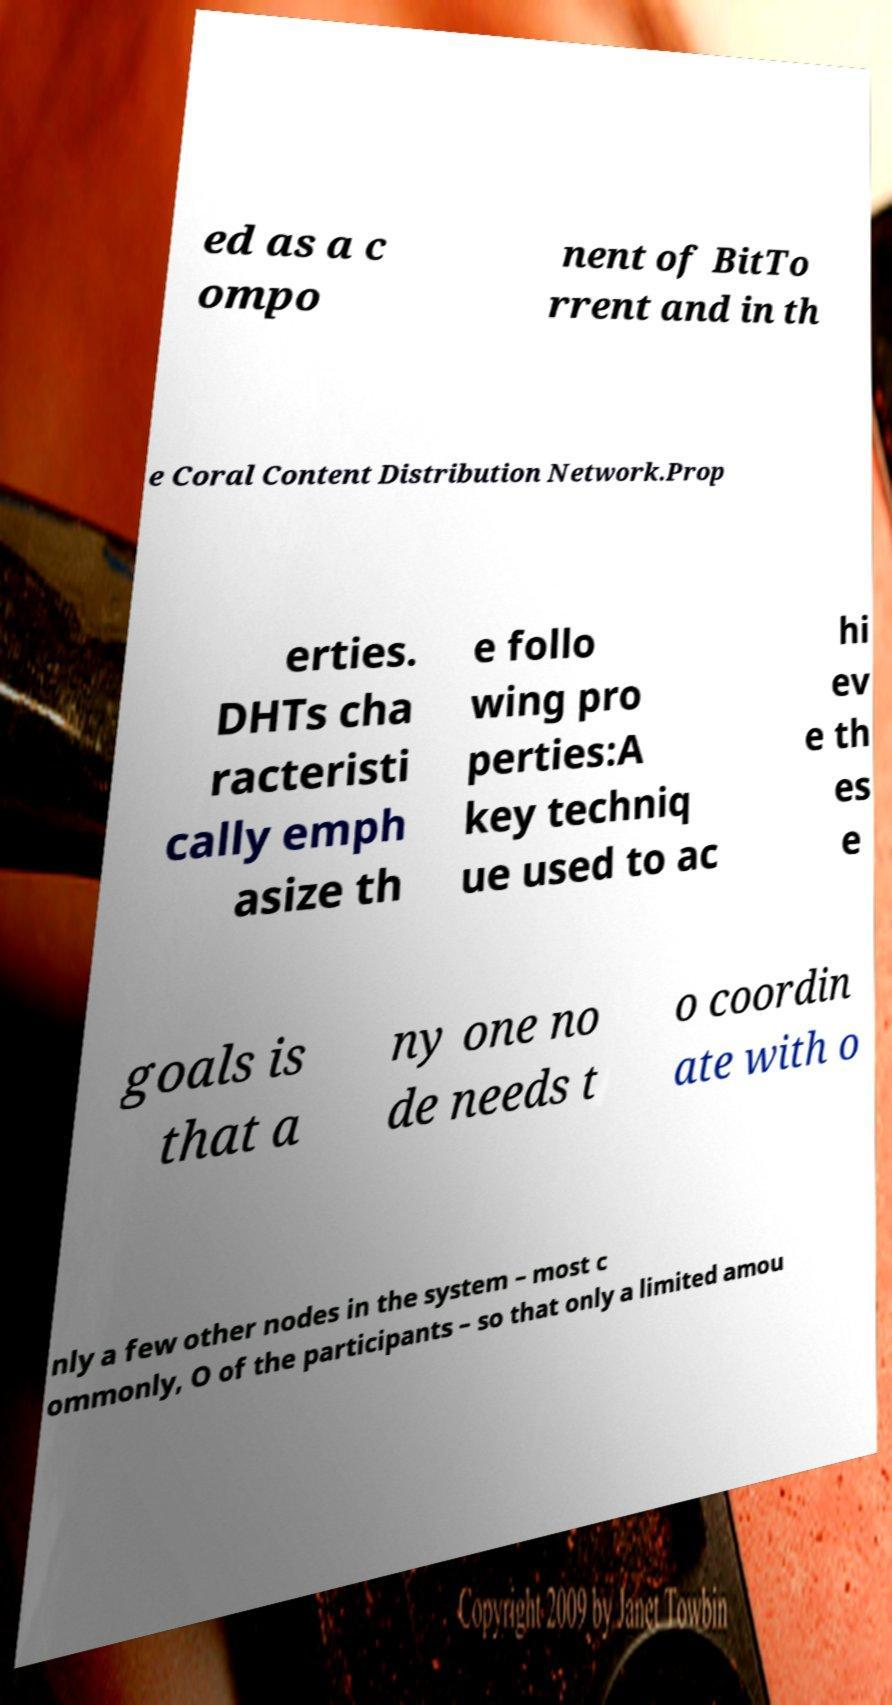For documentation purposes, I need the text within this image transcribed. Could you provide that? ed as a c ompo nent of BitTo rrent and in th e Coral Content Distribution Network.Prop erties. DHTs cha racteristi cally emph asize th e follo wing pro perties:A key techniq ue used to ac hi ev e th es e goals is that a ny one no de needs t o coordin ate with o nly a few other nodes in the system – most c ommonly, O of the participants – so that only a limited amou 